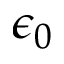<formula> <loc_0><loc_0><loc_500><loc_500>\epsilon _ { 0 }</formula> 